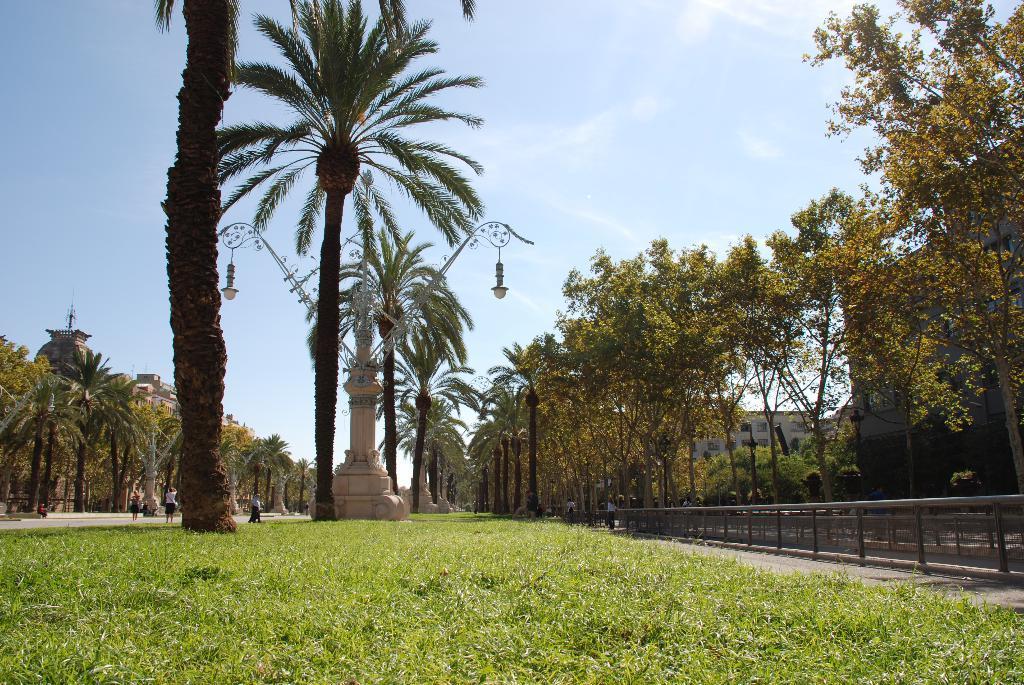Please provide a concise description of this image. In the background we can see the sky. In this picture we can the buildings, trees, people, lights, poles, grass, pillars, people and railings. 